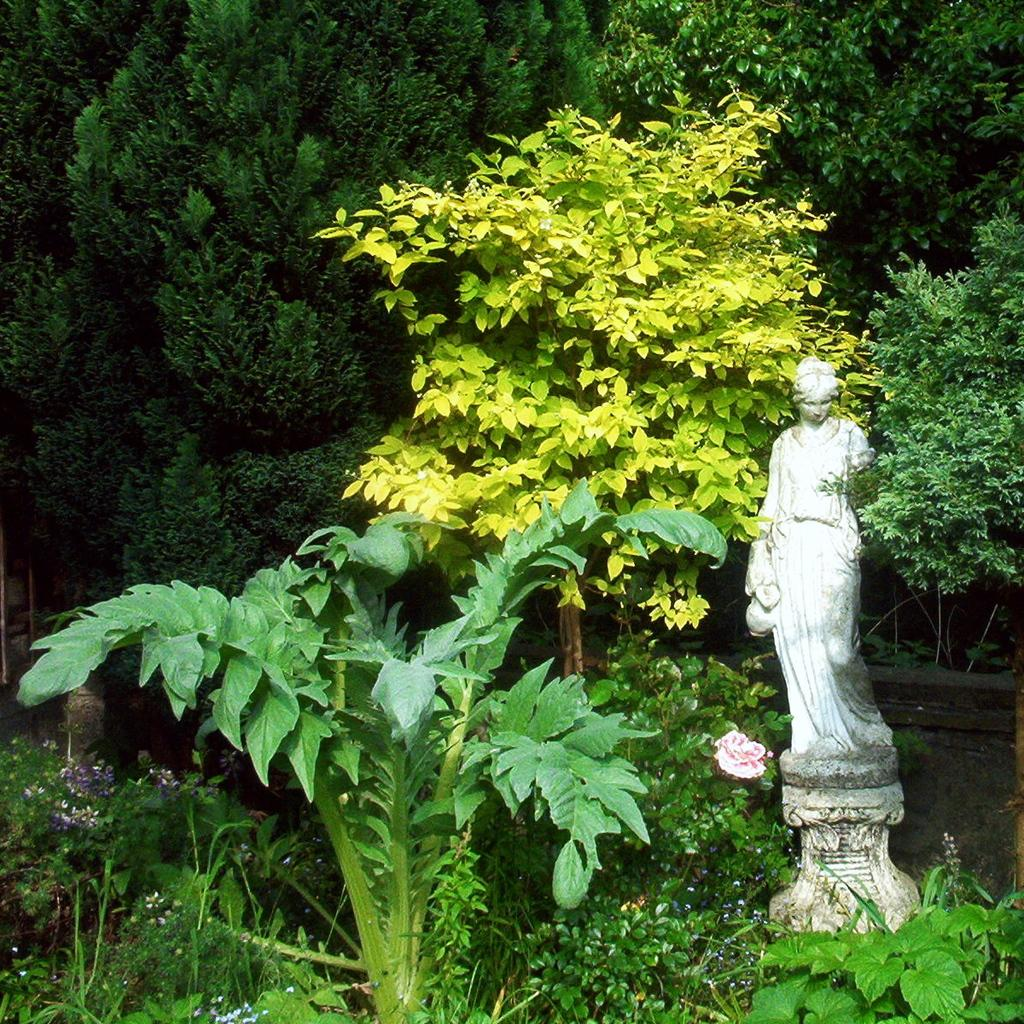What is the main subject in the image? There is a statue in the image. What other elements can be seen in the image besides the statue? There are plants, a flower, and trees visible in the image. How many chairs are visible in the image? There are no chairs present in the image. What type of front is visible in the image? There is no specific "front" visible in the image, as it is a still image of a statue, plants, a flower, and trees. 